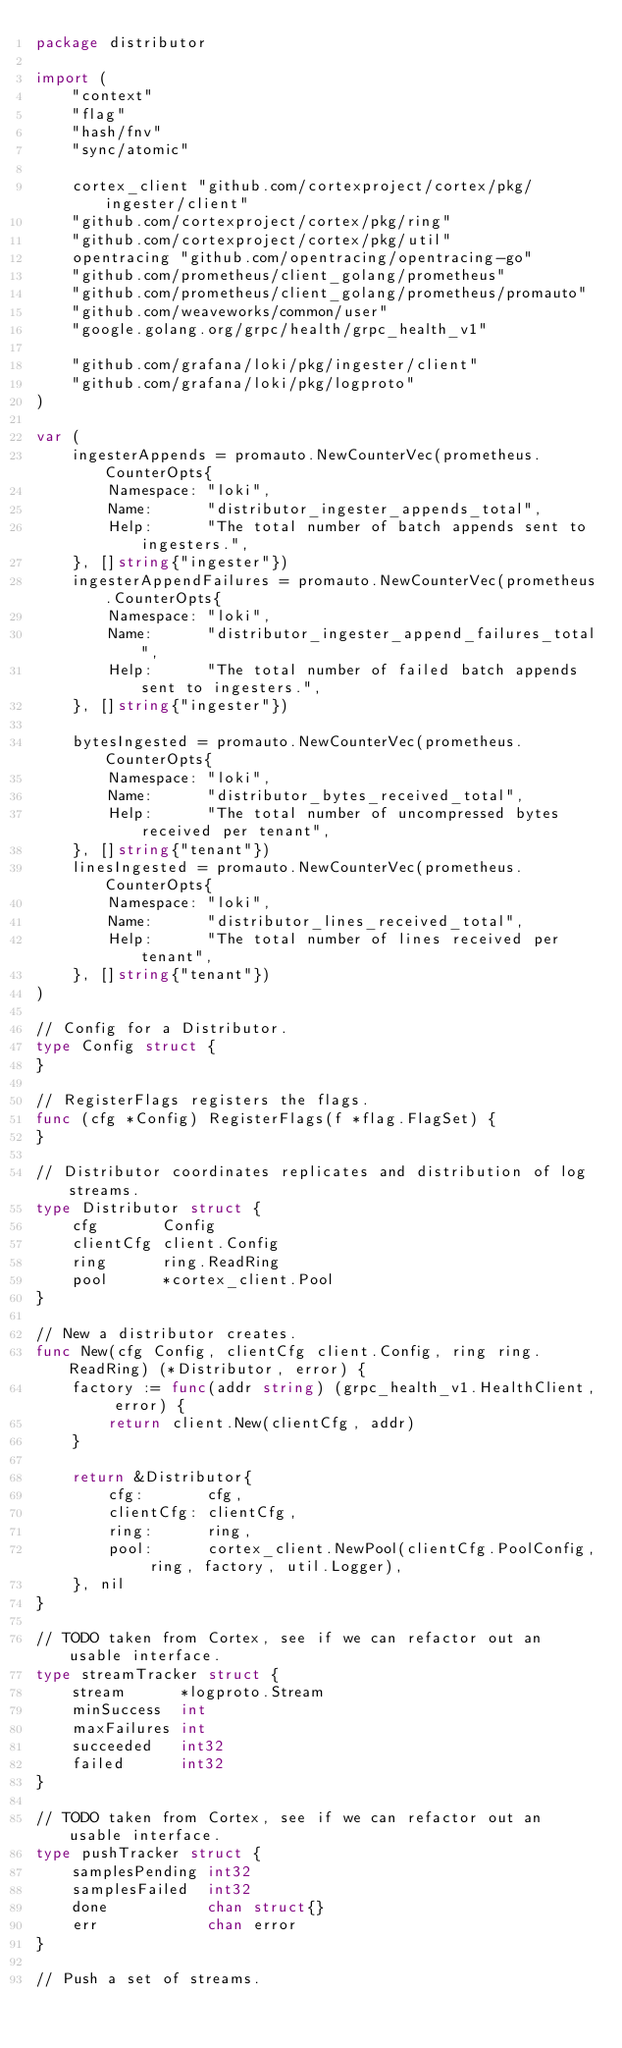Convert code to text. <code><loc_0><loc_0><loc_500><loc_500><_Go_>package distributor

import (
	"context"
	"flag"
	"hash/fnv"
	"sync/atomic"

	cortex_client "github.com/cortexproject/cortex/pkg/ingester/client"
	"github.com/cortexproject/cortex/pkg/ring"
	"github.com/cortexproject/cortex/pkg/util"
	opentracing "github.com/opentracing/opentracing-go"
	"github.com/prometheus/client_golang/prometheus"
	"github.com/prometheus/client_golang/prometheus/promauto"
	"github.com/weaveworks/common/user"
	"google.golang.org/grpc/health/grpc_health_v1"

	"github.com/grafana/loki/pkg/ingester/client"
	"github.com/grafana/loki/pkg/logproto"
)

var (
	ingesterAppends = promauto.NewCounterVec(prometheus.CounterOpts{
		Namespace: "loki",
		Name:      "distributor_ingester_appends_total",
		Help:      "The total number of batch appends sent to ingesters.",
	}, []string{"ingester"})
	ingesterAppendFailures = promauto.NewCounterVec(prometheus.CounterOpts{
		Namespace: "loki",
		Name:      "distributor_ingester_append_failures_total",
		Help:      "The total number of failed batch appends sent to ingesters.",
	}, []string{"ingester"})

	bytesIngested = promauto.NewCounterVec(prometheus.CounterOpts{
		Namespace: "loki",
		Name:      "distributor_bytes_received_total",
		Help:      "The total number of uncompressed bytes received per tenant",
	}, []string{"tenant"})
	linesIngested = promauto.NewCounterVec(prometheus.CounterOpts{
		Namespace: "loki",
		Name:      "distributor_lines_received_total",
		Help:      "The total number of lines received per tenant",
	}, []string{"tenant"})
)

// Config for a Distributor.
type Config struct {
}

// RegisterFlags registers the flags.
func (cfg *Config) RegisterFlags(f *flag.FlagSet) {
}

// Distributor coordinates replicates and distribution of log streams.
type Distributor struct {
	cfg       Config
	clientCfg client.Config
	ring      ring.ReadRing
	pool      *cortex_client.Pool
}

// New a distributor creates.
func New(cfg Config, clientCfg client.Config, ring ring.ReadRing) (*Distributor, error) {
	factory := func(addr string) (grpc_health_v1.HealthClient, error) {
		return client.New(clientCfg, addr)
	}

	return &Distributor{
		cfg:       cfg,
		clientCfg: clientCfg,
		ring:      ring,
		pool:      cortex_client.NewPool(clientCfg.PoolConfig, ring, factory, util.Logger),
	}, nil
}

// TODO taken from Cortex, see if we can refactor out an usable interface.
type streamTracker struct {
	stream      *logproto.Stream
	minSuccess  int
	maxFailures int
	succeeded   int32
	failed      int32
}

// TODO taken from Cortex, see if we can refactor out an usable interface.
type pushTracker struct {
	samplesPending int32
	samplesFailed  int32
	done           chan struct{}
	err            chan error
}

// Push a set of streams.</code> 